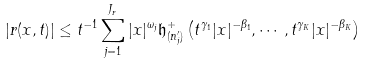<formula> <loc_0><loc_0><loc_500><loc_500>| { r } ( x , t ) | \leq t ^ { - 1 } \sum _ { j = 1 } ^ { J _ { r } } | x | ^ { \omega _ { j } } \mathfrak { h } ^ { + } _ { ( n ^ { \prime } _ { j } ) } \left ( t ^ { \gamma _ { 1 } } | x | ^ { - \beta _ { 1 } } , \cdots , t ^ { \gamma _ { K } } | x | ^ { - \beta _ { K } } \right )</formula> 